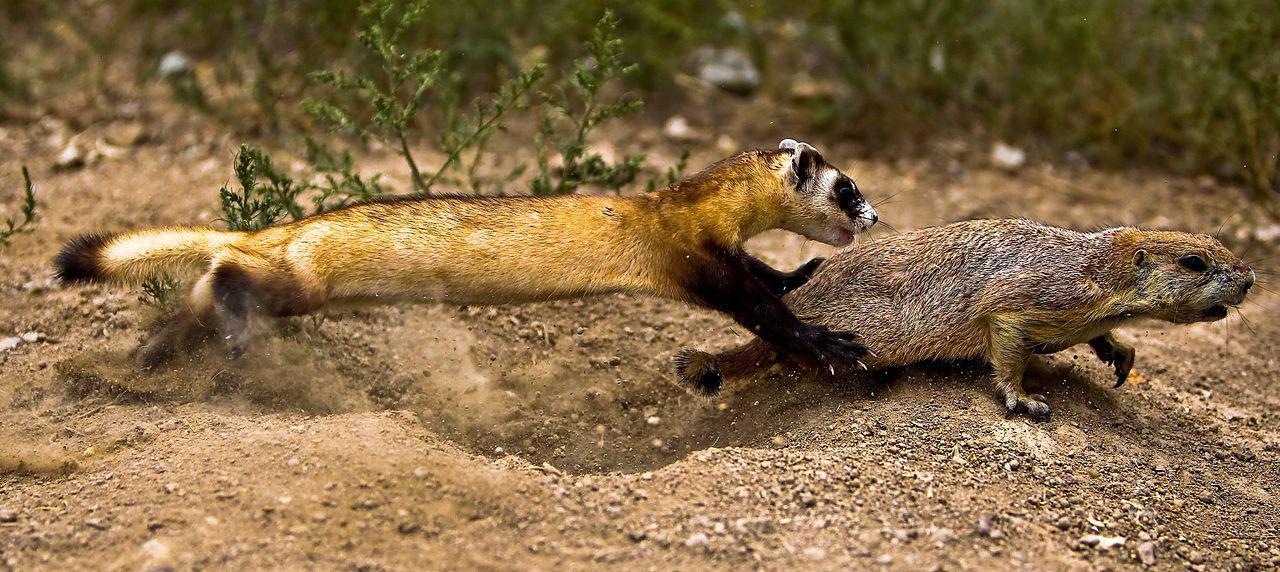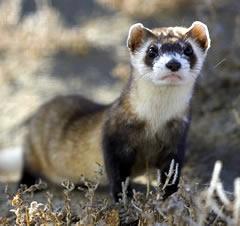The first image is the image on the left, the second image is the image on the right. Assess this claim about the two images: "The animal in one of the images has its body turned toward the bottom left". Correct or not? Answer yes or no. No. 